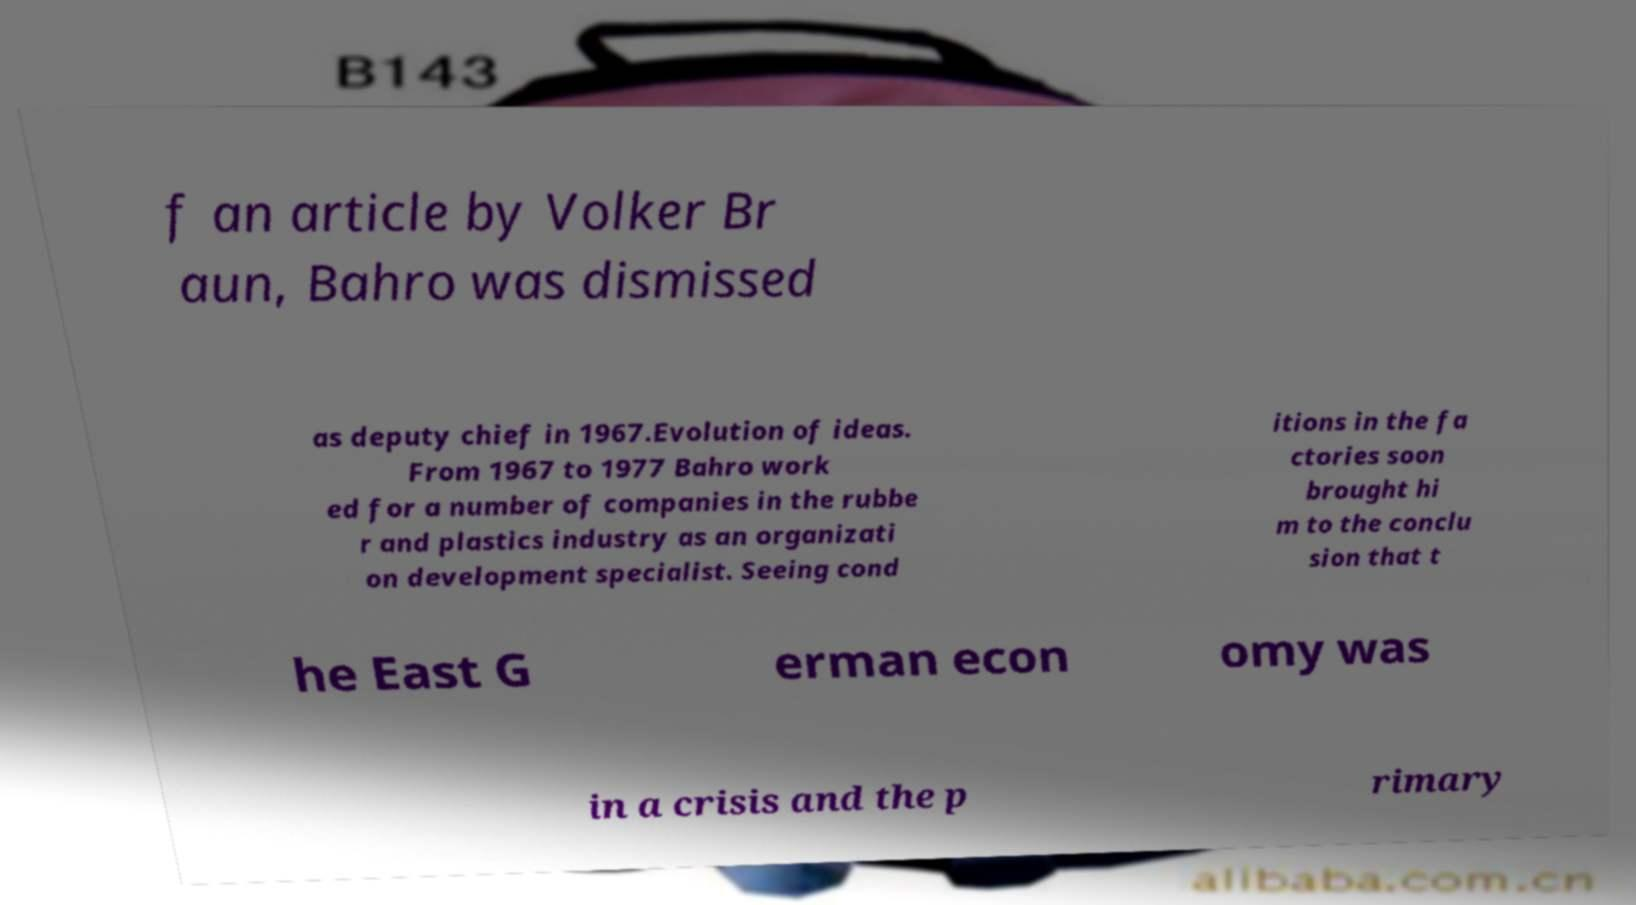I need the written content from this picture converted into text. Can you do that? f an article by Volker Br aun, Bahro was dismissed as deputy chief in 1967.Evolution of ideas. From 1967 to 1977 Bahro work ed for a number of companies in the rubbe r and plastics industry as an organizati on development specialist. Seeing cond itions in the fa ctories soon brought hi m to the conclu sion that t he East G erman econ omy was in a crisis and the p rimary 